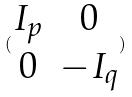<formula> <loc_0><loc_0><loc_500><loc_500>( \begin{matrix} I _ { p } & 0 \\ 0 & - I _ { q } \end{matrix} )</formula> 